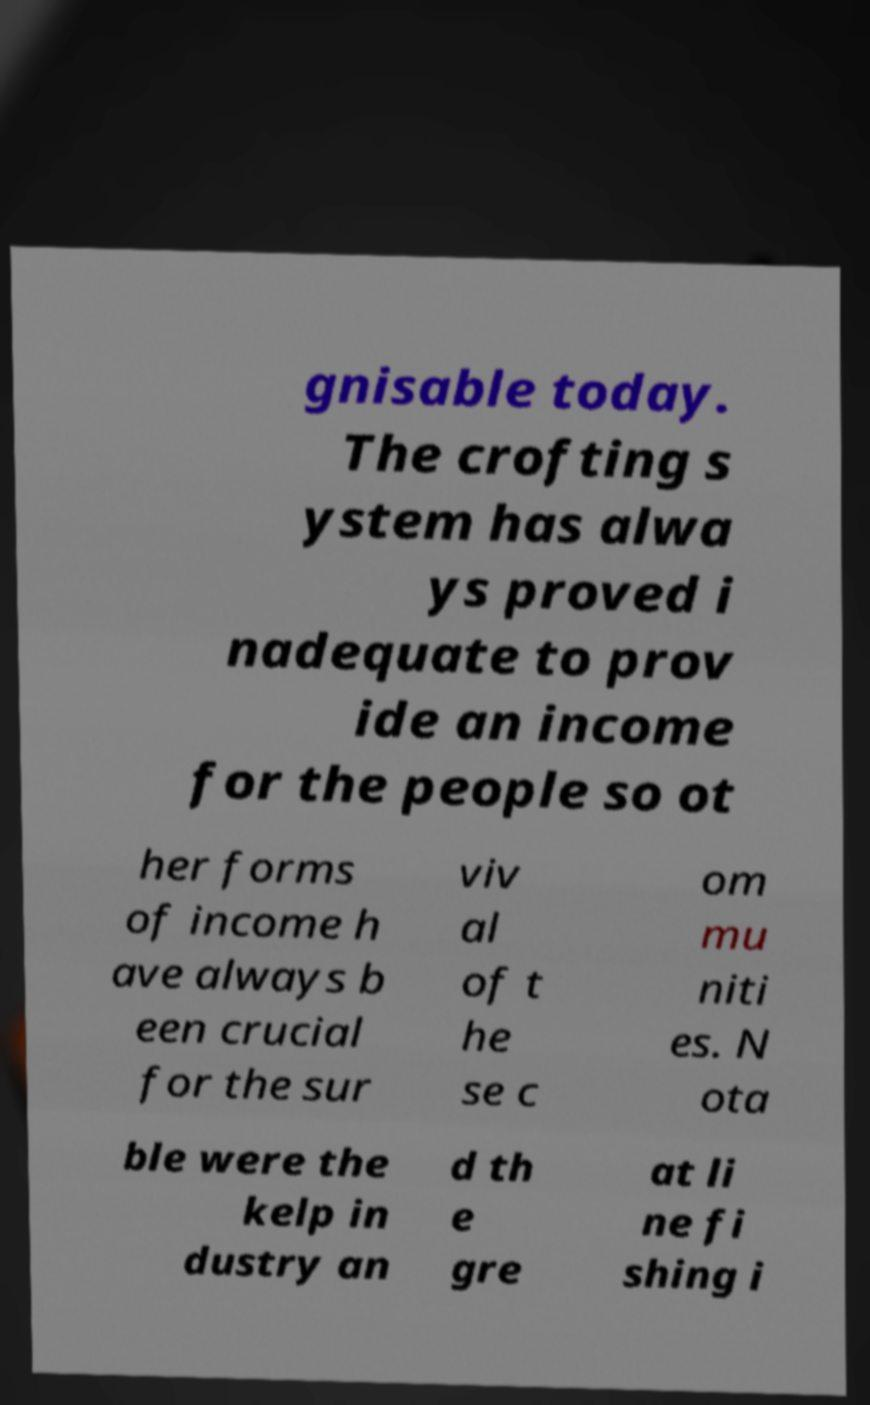Can you accurately transcribe the text from the provided image for me? gnisable today. The crofting s ystem has alwa ys proved i nadequate to prov ide an income for the people so ot her forms of income h ave always b een crucial for the sur viv al of t he se c om mu niti es. N ota ble were the kelp in dustry an d th e gre at li ne fi shing i 